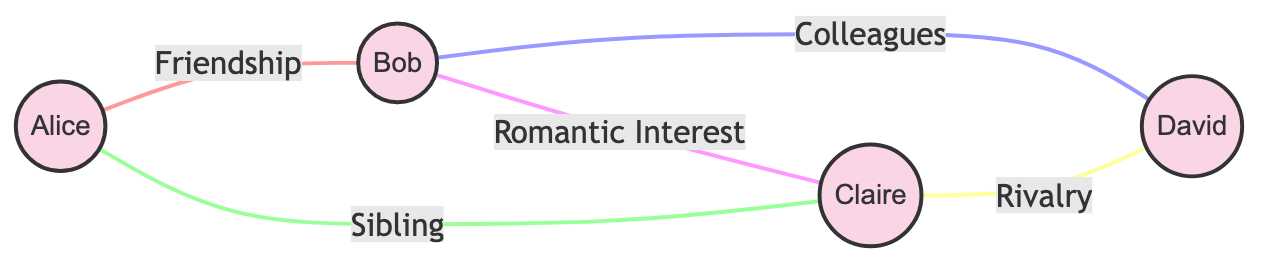What are the total number of characters in the script? The diagram lists four characters: Alice, Bob, Claire, and David. Therefore, by counting each character displayed, we can determine the total number.
Answer: 4 Which character has a sibling connection? According to the connections in the diagram, Alice has a sibling relationship with Claire. This can be established by looking for the label "Sibling" between them.
Answer: Alice What type of interaction exists between Bob and Claire? The diagram indicates a "Romantic Interest" connection between Bob and Claire. This is seen in the edge labeled with "Romantic Interest" connecting those two characters.
Answer: Romantic Interest Who is in rivalry with David? The diagram shows a direct connection labeled "Rivalry" between Claire and David, indicating that Claire is the character who is in rivalry with David.
Answer: Claire How many total connections are there in the network? By counting each connection listed in the diagram (the edges), we find that there are five connections in total between the characters.
Answer: 5 Which character connects to both Bob and David? By tracing the connections from the diagram, we see that Bob connects to David through a "Colleagues" relationship, while also connecting to Claire with both "Romantic Interest" and "Friendship" connections, making Bob the character in this situation.
Answer: Bob What is the interaction type between Alice and Bob? The diagram specifically labels the interaction between Alice and Bob as "Friendship." Hence, by checking the edge between Alice and Bob, we confirm this type of interaction.
Answer: Friendship Which two characters have the strongest negative connection? The strongest negative connection can be inferred to be "Rivalry," which exists between Claire and David. Checking the connection labels shows this is the only rivalry in the network.
Answer: Claire and David 